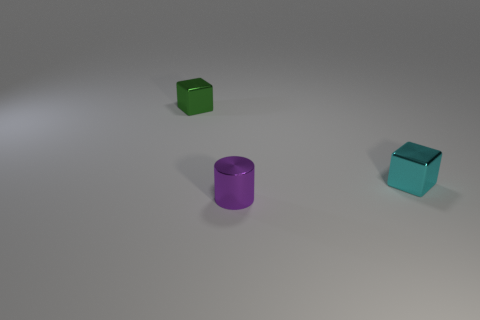Is the number of metal things behind the tiny purple object the same as the number of big gray metallic objects?
Offer a terse response. No. What number of small blocks are both on the right side of the small green metal object and on the left side of the cylinder?
Offer a very short reply. 0. Does the small metallic object that is behind the tiny cyan metallic object have the same shape as the cyan thing?
Your response must be concise. Yes. There is a green thing that is the same size as the purple object; what is its material?
Offer a very short reply. Metal. Is the number of small metal objects behind the small cyan shiny object the same as the number of cubes that are to the left of the tiny purple shiny cylinder?
Your answer should be very brief. Yes. There is a purple shiny cylinder that is in front of the object that is right of the small purple cylinder; what number of tiny blocks are behind it?
Your response must be concise. 2. Is the number of tiny metal blocks that are in front of the green shiny object greater than the number of small brown blocks?
Offer a terse response. Yes. There is a tiny block behind the small block that is right of the block that is left of the cyan metal cube; what is its material?
Your answer should be very brief. Metal. Are there more metallic blocks on the left side of the tiny purple cylinder than tiny shiny cubes to the left of the small green object?
Your answer should be very brief. Yes. There is a small purple object that is the same material as the small cyan cube; what shape is it?
Your answer should be compact. Cylinder. 